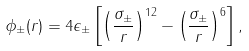<formula> <loc_0><loc_0><loc_500><loc_500>\phi _ { \pm } ( r ) = 4 \epsilon _ { \pm } \left [ \left ( \frac { \sigma _ { \pm } } { r } \right ) ^ { 1 2 } - \left ( \frac { \sigma _ { \pm } } { r } \right ) ^ { 6 } \right ] ,</formula> 